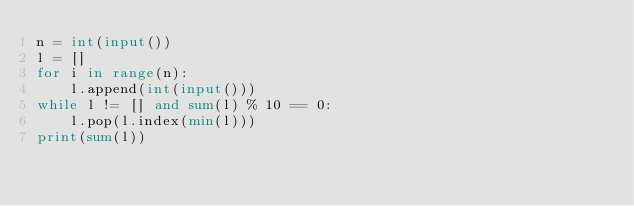<code> <loc_0><loc_0><loc_500><loc_500><_Python_>n = int(input())
l = []
for i in range(n):
    l.append(int(input()))
while l != [] and sum(l) % 10 == 0:
    l.pop(l.index(min(l)))
print(sum(l))
</code> 